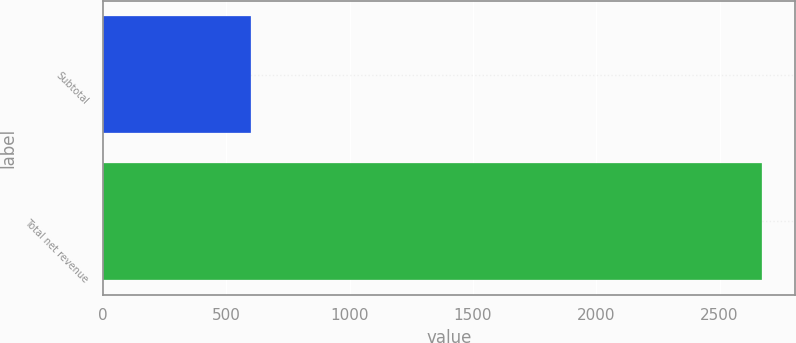<chart> <loc_0><loc_0><loc_500><loc_500><bar_chart><fcel>Subtotal<fcel>Total net revenue<nl><fcel>598.2<fcel>2672.9<nl></chart> 